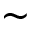Convert formula to latex. <formula><loc_0><loc_0><loc_500><loc_500>\sim</formula> 